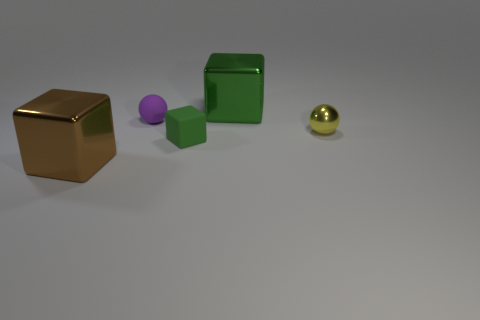Add 2 blue things. How many objects exist? 7 Subtract all cubes. How many objects are left? 2 Add 3 small blocks. How many small blocks exist? 4 Subtract all green cubes. How many cubes are left? 1 Subtract all big blocks. How many blocks are left? 1 Subtract 0 red cubes. How many objects are left? 5 Subtract 2 spheres. How many spheres are left? 0 Subtract all yellow balls. Subtract all purple blocks. How many balls are left? 1 Subtract all cyan spheres. How many brown cubes are left? 1 Subtract all tiny purple spheres. Subtract all tiny yellow metallic spheres. How many objects are left? 3 